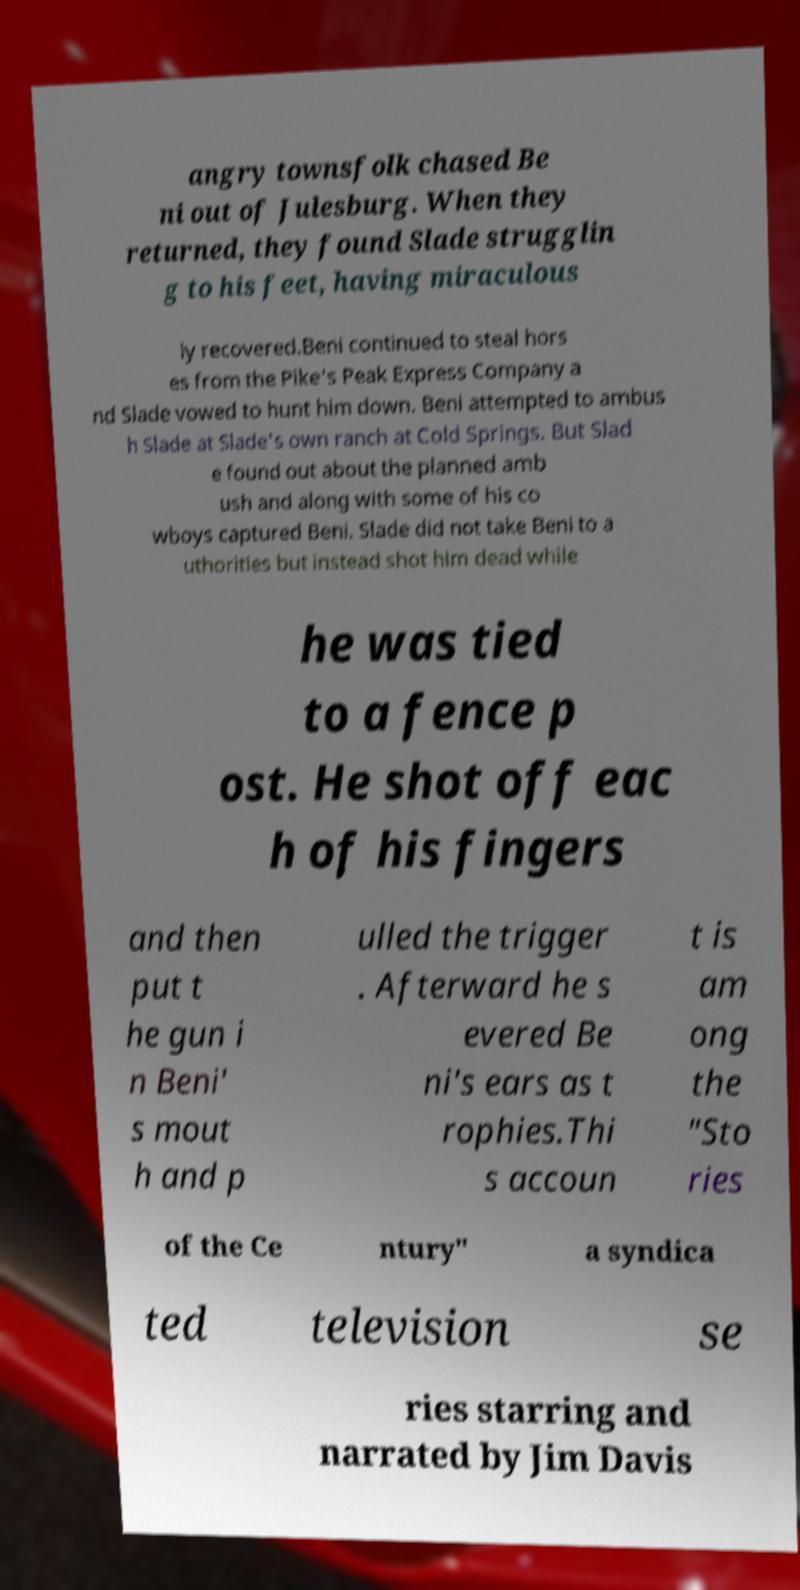Please identify and transcribe the text found in this image. angry townsfolk chased Be ni out of Julesburg. When they returned, they found Slade strugglin g to his feet, having miraculous ly recovered.Beni continued to steal hors es from the Pike's Peak Express Company a nd Slade vowed to hunt him down. Beni attempted to ambus h Slade at Slade's own ranch at Cold Springs. But Slad e found out about the planned amb ush and along with some of his co wboys captured Beni. Slade did not take Beni to a uthorities but instead shot him dead while he was tied to a fence p ost. He shot off eac h of his fingers and then put t he gun i n Beni' s mout h and p ulled the trigger . Afterward he s evered Be ni's ears as t rophies.Thi s accoun t is am ong the "Sto ries of the Ce ntury" a syndica ted television se ries starring and narrated by Jim Davis 